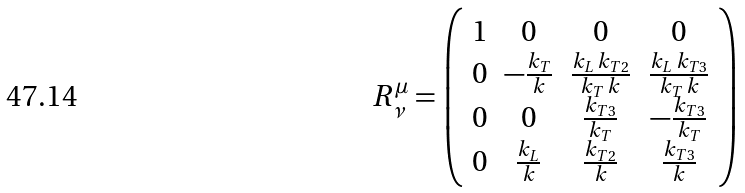Convert formula to latex. <formula><loc_0><loc_0><loc_500><loc_500>R ^ { \mu } _ { \nu } = \left ( \begin{array} { c c c c } 1 & 0 & 0 & 0 \\ 0 & - \frac { k _ { T } } { k } & \frac { k _ { L } \, k _ { T 2 } } { k _ { T } \, k } & \frac { k _ { L } \, k _ { T 3 } } { k _ { T } \, k } \\ 0 & 0 & \frac { k _ { T 3 } } { k _ { T } } & - \frac { k _ { T 3 } } { k _ { T } } \\ 0 & \frac { k _ { L } } { k } & \frac { k _ { T 2 } } { k } & \frac { k _ { T 3 } } { k } \end{array} \right )</formula> 